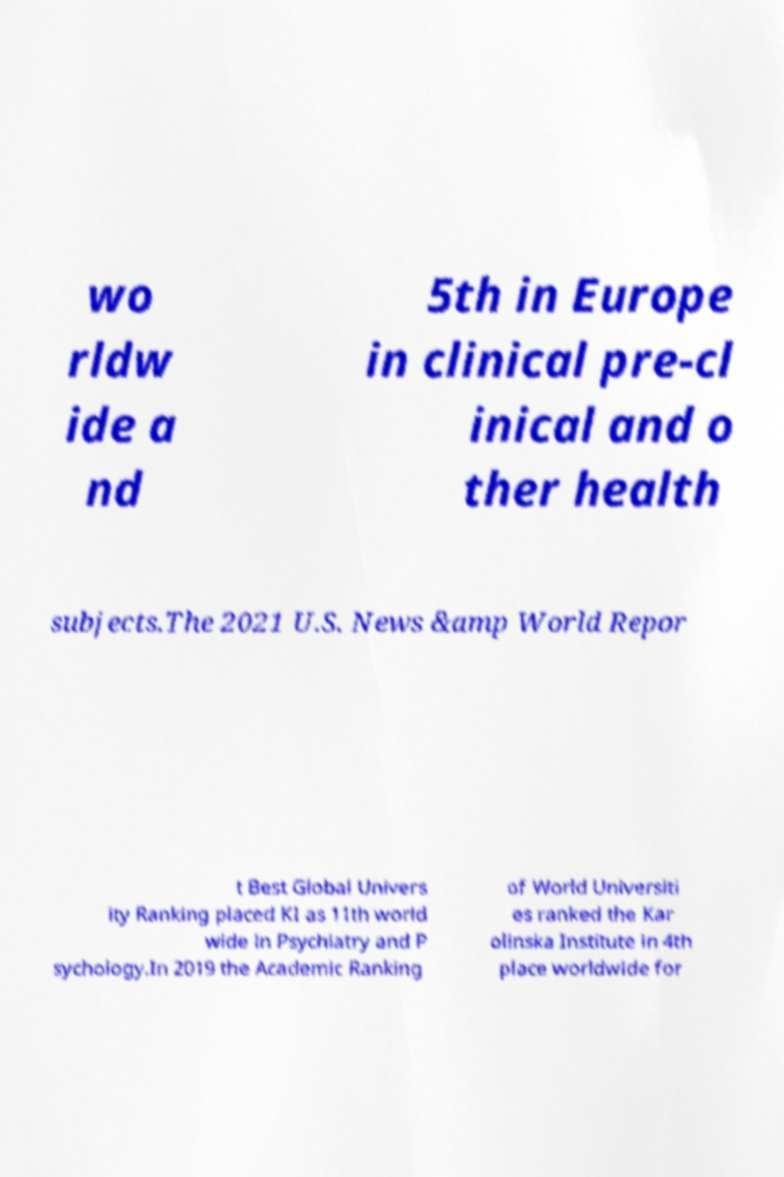Can you read and provide the text displayed in the image?This photo seems to have some interesting text. Can you extract and type it out for me? wo rldw ide a nd 5th in Europe in clinical pre-cl inical and o ther health subjects.The 2021 U.S. News &amp World Repor t Best Global Univers ity Ranking placed KI as 11th world wide in Psychiatry and P sychology.In 2019 the Academic Ranking of World Universiti es ranked the Kar olinska Institute in 4th place worldwide for 